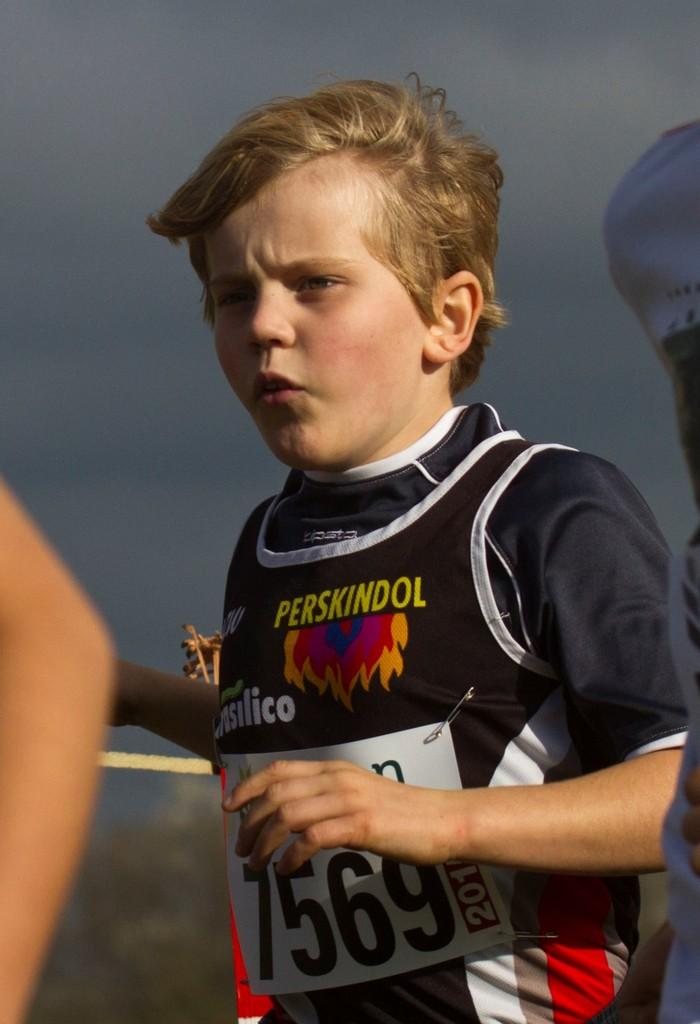<image>
Summarize the visual content of the image. A kid wearing a perskindol shirt appears ready for the race. 